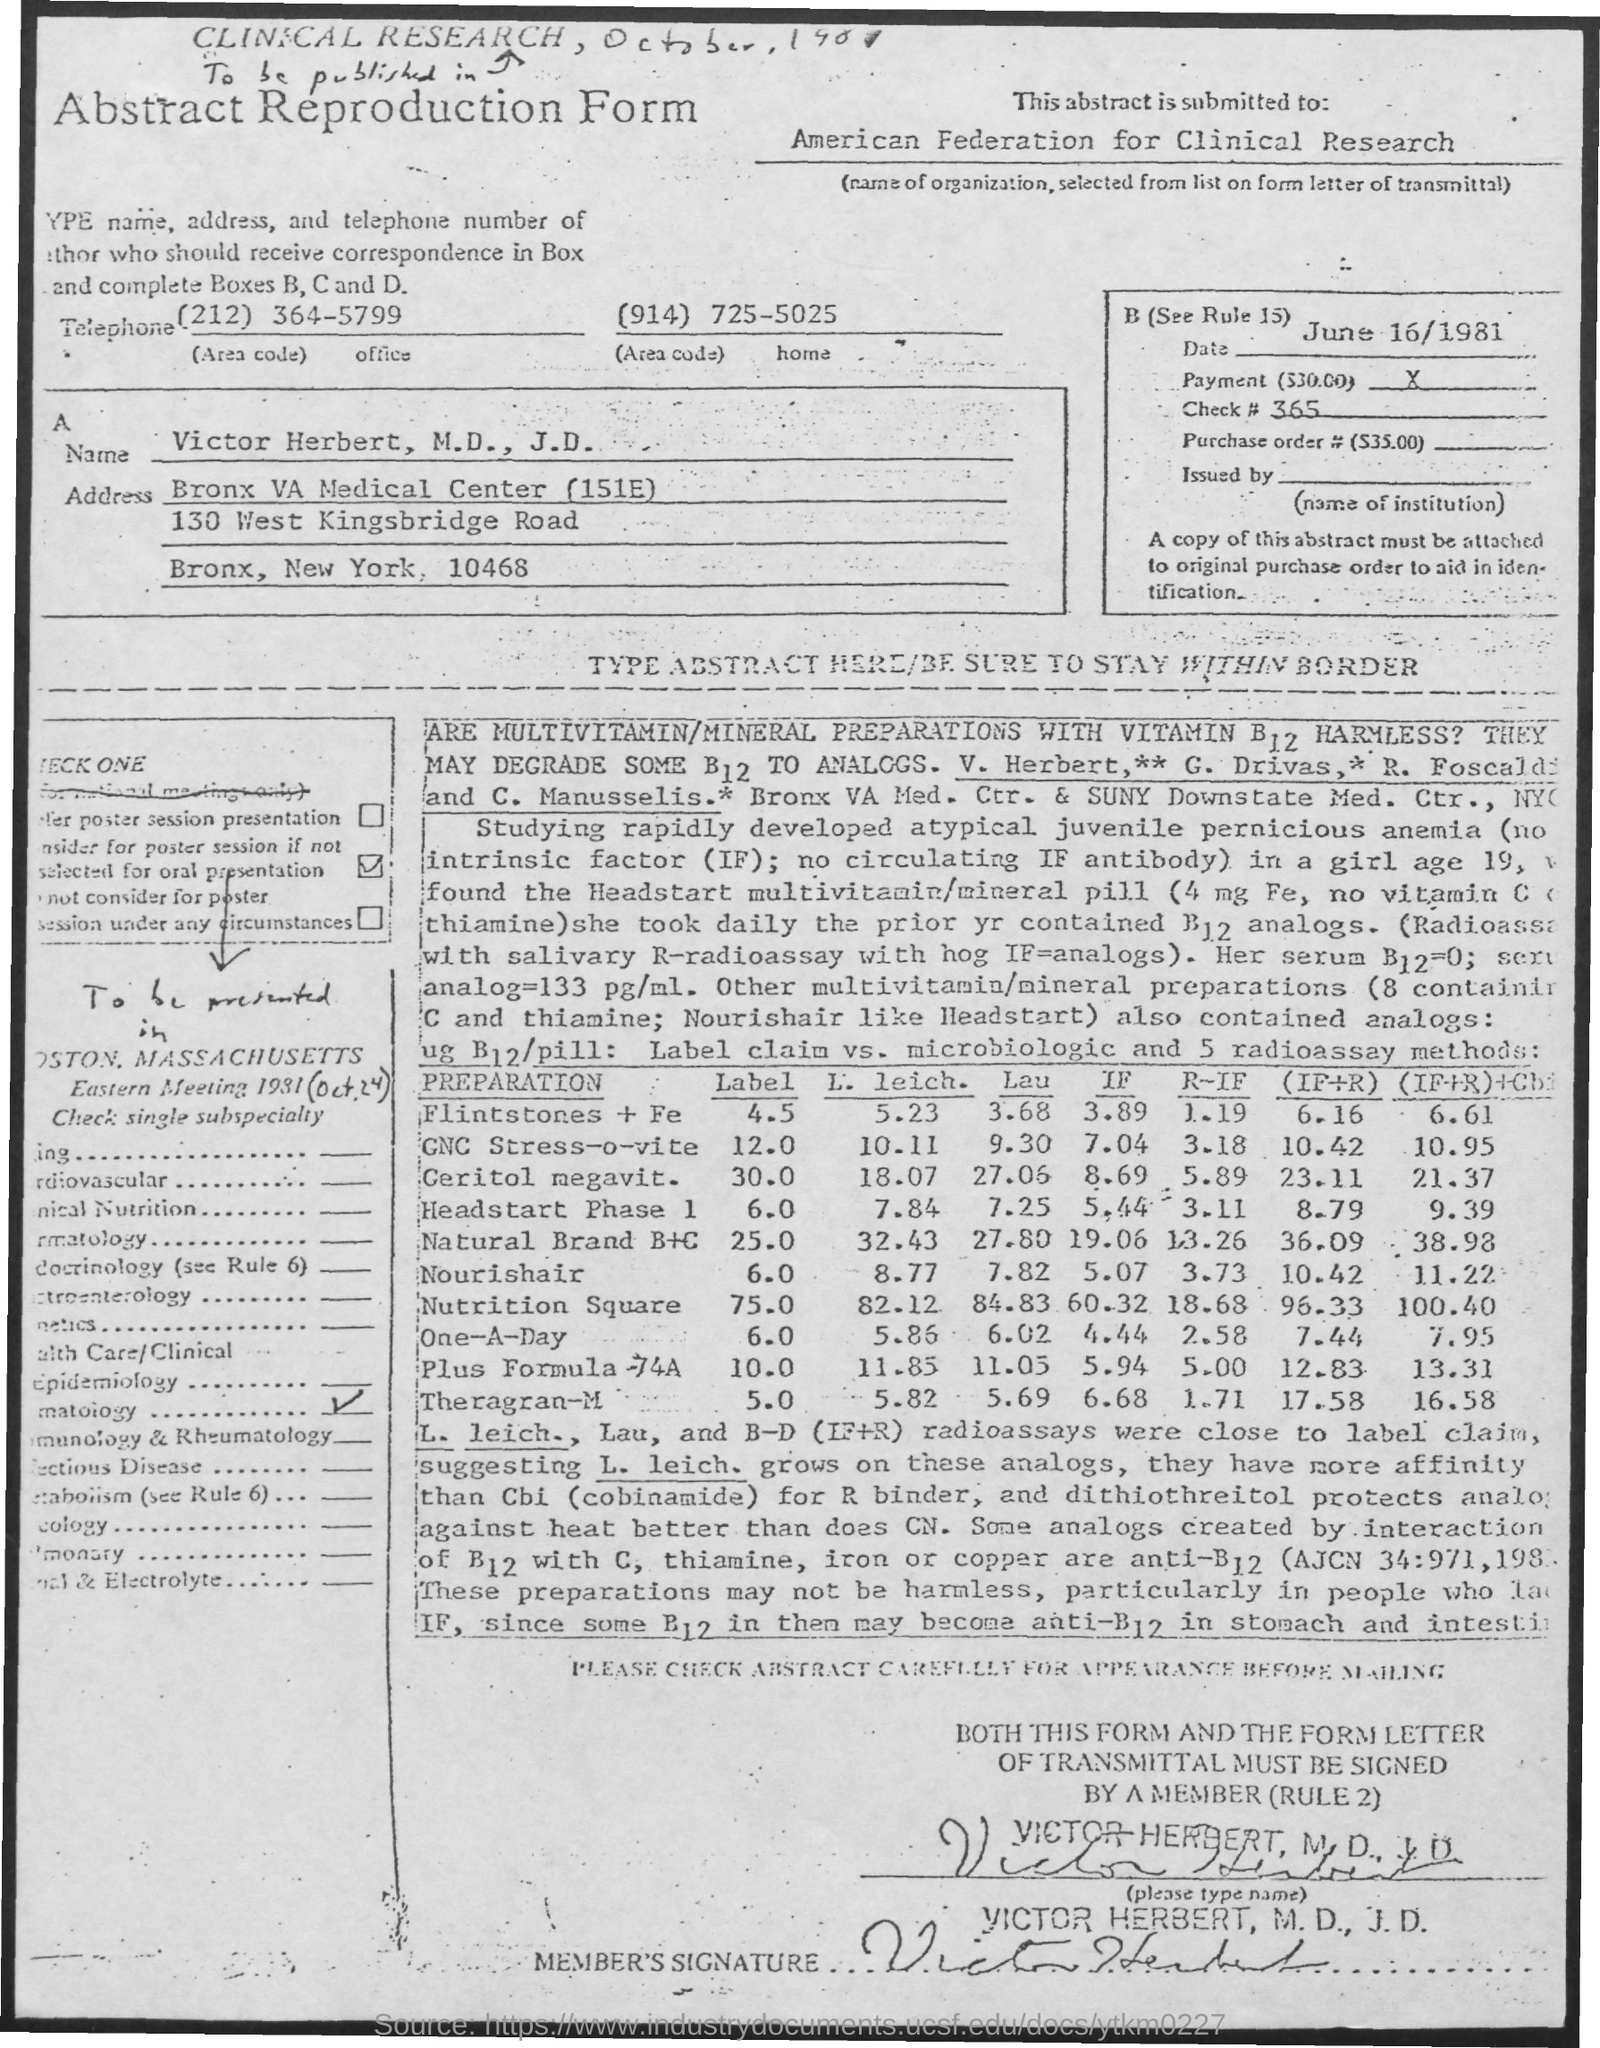What is the Title of the document?
Keep it short and to the point. Abstract Reproduction Form. This abstract is submitted to whom?
Make the answer very short. American Federation for Clinical Research. What is the date on the document?
Offer a very short reply. June 16/1981. What is the office telephone number?
Ensure brevity in your answer.  (212) 364-5799. What is the home telephone number?
Your response must be concise. (914) 725-5025. 